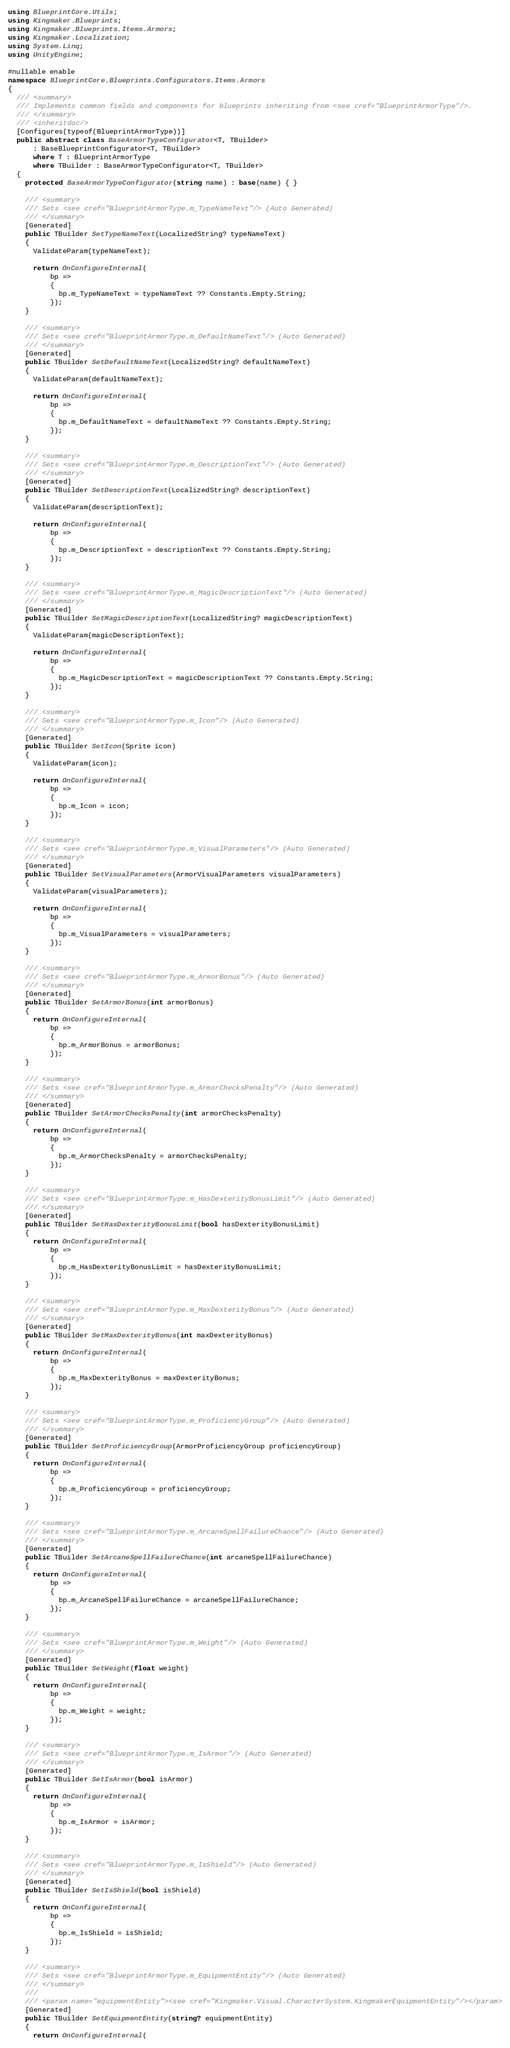Convert code to text. <code><loc_0><loc_0><loc_500><loc_500><_C#_>using BlueprintCore.Utils;
using Kingmaker.Blueprints;
using Kingmaker.Blueprints.Items.Armors;
using Kingmaker.Localization;
using System.Linq;
using UnityEngine;

#nullable enable
namespace BlueprintCore.Blueprints.Configurators.Items.Armors
{
  /// <summary>
  /// Implements common fields and components for blueprints inheriting from <see cref="BlueprintArmorType"/>.
  /// </summary>
  /// <inheritdoc/>
  [Configures(typeof(BlueprintArmorType))]
  public abstract class BaseArmorTypeConfigurator<T, TBuilder>
      : BaseBlueprintConfigurator<T, TBuilder>
      where T : BlueprintArmorType
      where TBuilder : BaseArmorTypeConfigurator<T, TBuilder>
  {
    protected BaseArmorTypeConfigurator(string name) : base(name) { }

    /// <summary>
    /// Sets <see cref="BlueprintArmorType.m_TypeNameText"/> (Auto Generated)
    /// </summary>
    [Generated]
    public TBuilder SetTypeNameText(LocalizedString? typeNameText)
    {
      ValidateParam(typeNameText);
    
      return OnConfigureInternal(
          bp =>
          {
            bp.m_TypeNameText = typeNameText ?? Constants.Empty.String;
          });
    }

    /// <summary>
    /// Sets <see cref="BlueprintArmorType.m_DefaultNameText"/> (Auto Generated)
    /// </summary>
    [Generated]
    public TBuilder SetDefaultNameText(LocalizedString? defaultNameText)
    {
      ValidateParam(defaultNameText);
    
      return OnConfigureInternal(
          bp =>
          {
            bp.m_DefaultNameText = defaultNameText ?? Constants.Empty.String;
          });
    }

    /// <summary>
    /// Sets <see cref="BlueprintArmorType.m_DescriptionText"/> (Auto Generated)
    /// </summary>
    [Generated]
    public TBuilder SetDescriptionText(LocalizedString? descriptionText)
    {
      ValidateParam(descriptionText);
    
      return OnConfigureInternal(
          bp =>
          {
            bp.m_DescriptionText = descriptionText ?? Constants.Empty.String;
          });
    }

    /// <summary>
    /// Sets <see cref="BlueprintArmorType.m_MagicDescriptionText"/> (Auto Generated)
    /// </summary>
    [Generated]
    public TBuilder SetMagicDescriptionText(LocalizedString? magicDescriptionText)
    {
      ValidateParam(magicDescriptionText);
    
      return OnConfigureInternal(
          bp =>
          {
            bp.m_MagicDescriptionText = magicDescriptionText ?? Constants.Empty.String;
          });
    }

    /// <summary>
    /// Sets <see cref="BlueprintArmorType.m_Icon"/> (Auto Generated)
    /// </summary>
    [Generated]
    public TBuilder SetIcon(Sprite icon)
    {
      ValidateParam(icon);
    
      return OnConfigureInternal(
          bp =>
          {
            bp.m_Icon = icon;
          });
    }

    /// <summary>
    /// Sets <see cref="BlueprintArmorType.m_VisualParameters"/> (Auto Generated)
    /// </summary>
    [Generated]
    public TBuilder SetVisualParameters(ArmorVisualParameters visualParameters)
    {
      ValidateParam(visualParameters);
    
      return OnConfigureInternal(
          bp =>
          {
            bp.m_VisualParameters = visualParameters;
          });
    }

    /// <summary>
    /// Sets <see cref="BlueprintArmorType.m_ArmorBonus"/> (Auto Generated)
    /// </summary>
    [Generated]
    public TBuilder SetArmorBonus(int armorBonus)
    {
      return OnConfigureInternal(
          bp =>
          {
            bp.m_ArmorBonus = armorBonus;
          });
    }

    /// <summary>
    /// Sets <see cref="BlueprintArmorType.m_ArmorChecksPenalty"/> (Auto Generated)
    /// </summary>
    [Generated]
    public TBuilder SetArmorChecksPenalty(int armorChecksPenalty)
    {
      return OnConfigureInternal(
          bp =>
          {
            bp.m_ArmorChecksPenalty = armorChecksPenalty;
          });
    }

    /// <summary>
    /// Sets <see cref="BlueprintArmorType.m_HasDexterityBonusLimit"/> (Auto Generated)
    /// </summary>
    [Generated]
    public TBuilder SetHasDexterityBonusLimit(bool hasDexterityBonusLimit)
    {
      return OnConfigureInternal(
          bp =>
          {
            bp.m_HasDexterityBonusLimit = hasDexterityBonusLimit;
          });
    }

    /// <summary>
    /// Sets <see cref="BlueprintArmorType.m_MaxDexterityBonus"/> (Auto Generated)
    /// </summary>
    [Generated]
    public TBuilder SetMaxDexterityBonus(int maxDexterityBonus)
    {
      return OnConfigureInternal(
          bp =>
          {
            bp.m_MaxDexterityBonus = maxDexterityBonus;
          });
    }

    /// <summary>
    /// Sets <see cref="BlueprintArmorType.m_ProficiencyGroup"/> (Auto Generated)
    /// </summary>
    [Generated]
    public TBuilder SetProficiencyGroup(ArmorProficiencyGroup proficiencyGroup)
    {
      return OnConfigureInternal(
          bp =>
          {
            bp.m_ProficiencyGroup = proficiencyGroup;
          });
    }

    /// <summary>
    /// Sets <see cref="BlueprintArmorType.m_ArcaneSpellFailureChance"/> (Auto Generated)
    /// </summary>
    [Generated]
    public TBuilder SetArcaneSpellFailureChance(int arcaneSpellFailureChance)
    {
      return OnConfigureInternal(
          bp =>
          {
            bp.m_ArcaneSpellFailureChance = arcaneSpellFailureChance;
          });
    }

    /// <summary>
    /// Sets <see cref="BlueprintArmorType.m_Weight"/> (Auto Generated)
    /// </summary>
    [Generated]
    public TBuilder SetWeight(float weight)
    {
      return OnConfigureInternal(
          bp =>
          {
            bp.m_Weight = weight;
          });
    }

    /// <summary>
    /// Sets <see cref="BlueprintArmorType.m_IsArmor"/> (Auto Generated)
    /// </summary>
    [Generated]
    public TBuilder SetIsArmor(bool isArmor)
    {
      return OnConfigureInternal(
          bp =>
          {
            bp.m_IsArmor = isArmor;
          });
    }

    /// <summary>
    /// Sets <see cref="BlueprintArmorType.m_IsShield"/> (Auto Generated)
    /// </summary>
    [Generated]
    public TBuilder SetIsShield(bool isShield)
    {
      return OnConfigureInternal(
          bp =>
          {
            bp.m_IsShield = isShield;
          });
    }

    /// <summary>
    /// Sets <see cref="BlueprintArmorType.m_EquipmentEntity"/> (Auto Generated)
    /// </summary>
    ///
    /// <param name="equipmentEntity"><see cref="Kingmaker.Visual.CharacterSystem.KingmakerEquipmentEntity"/></param>
    [Generated]
    public TBuilder SetEquipmentEntity(string? equipmentEntity)
    {
      return OnConfigureInternal(</code> 